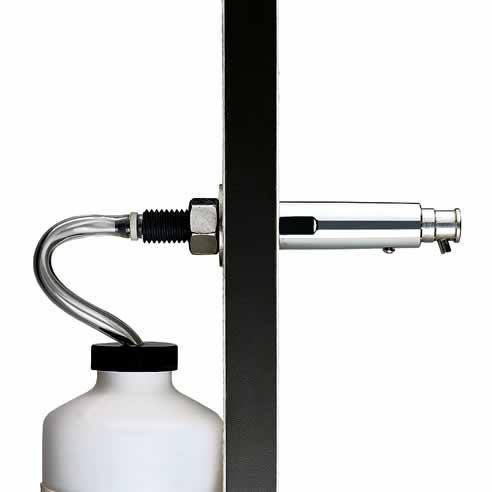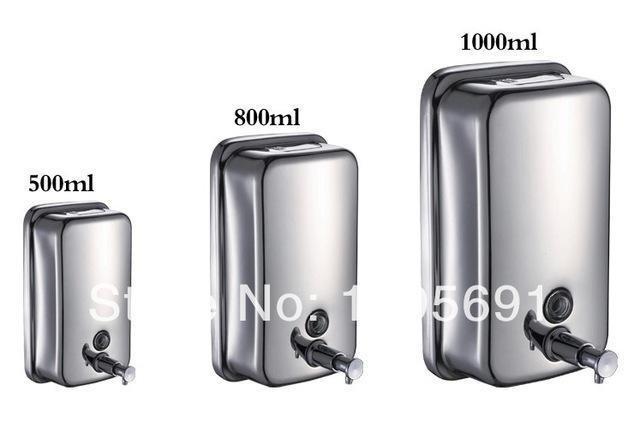The first image is the image on the left, the second image is the image on the right. Considering the images on both sides, is "The left and right image contains the same number of sink soap dispensers." valid? Answer yes or no. No. The first image is the image on the left, the second image is the image on the right. For the images shown, is this caption "There is one dispenser attached to a plastic bottle." true? Answer yes or no. Yes. 